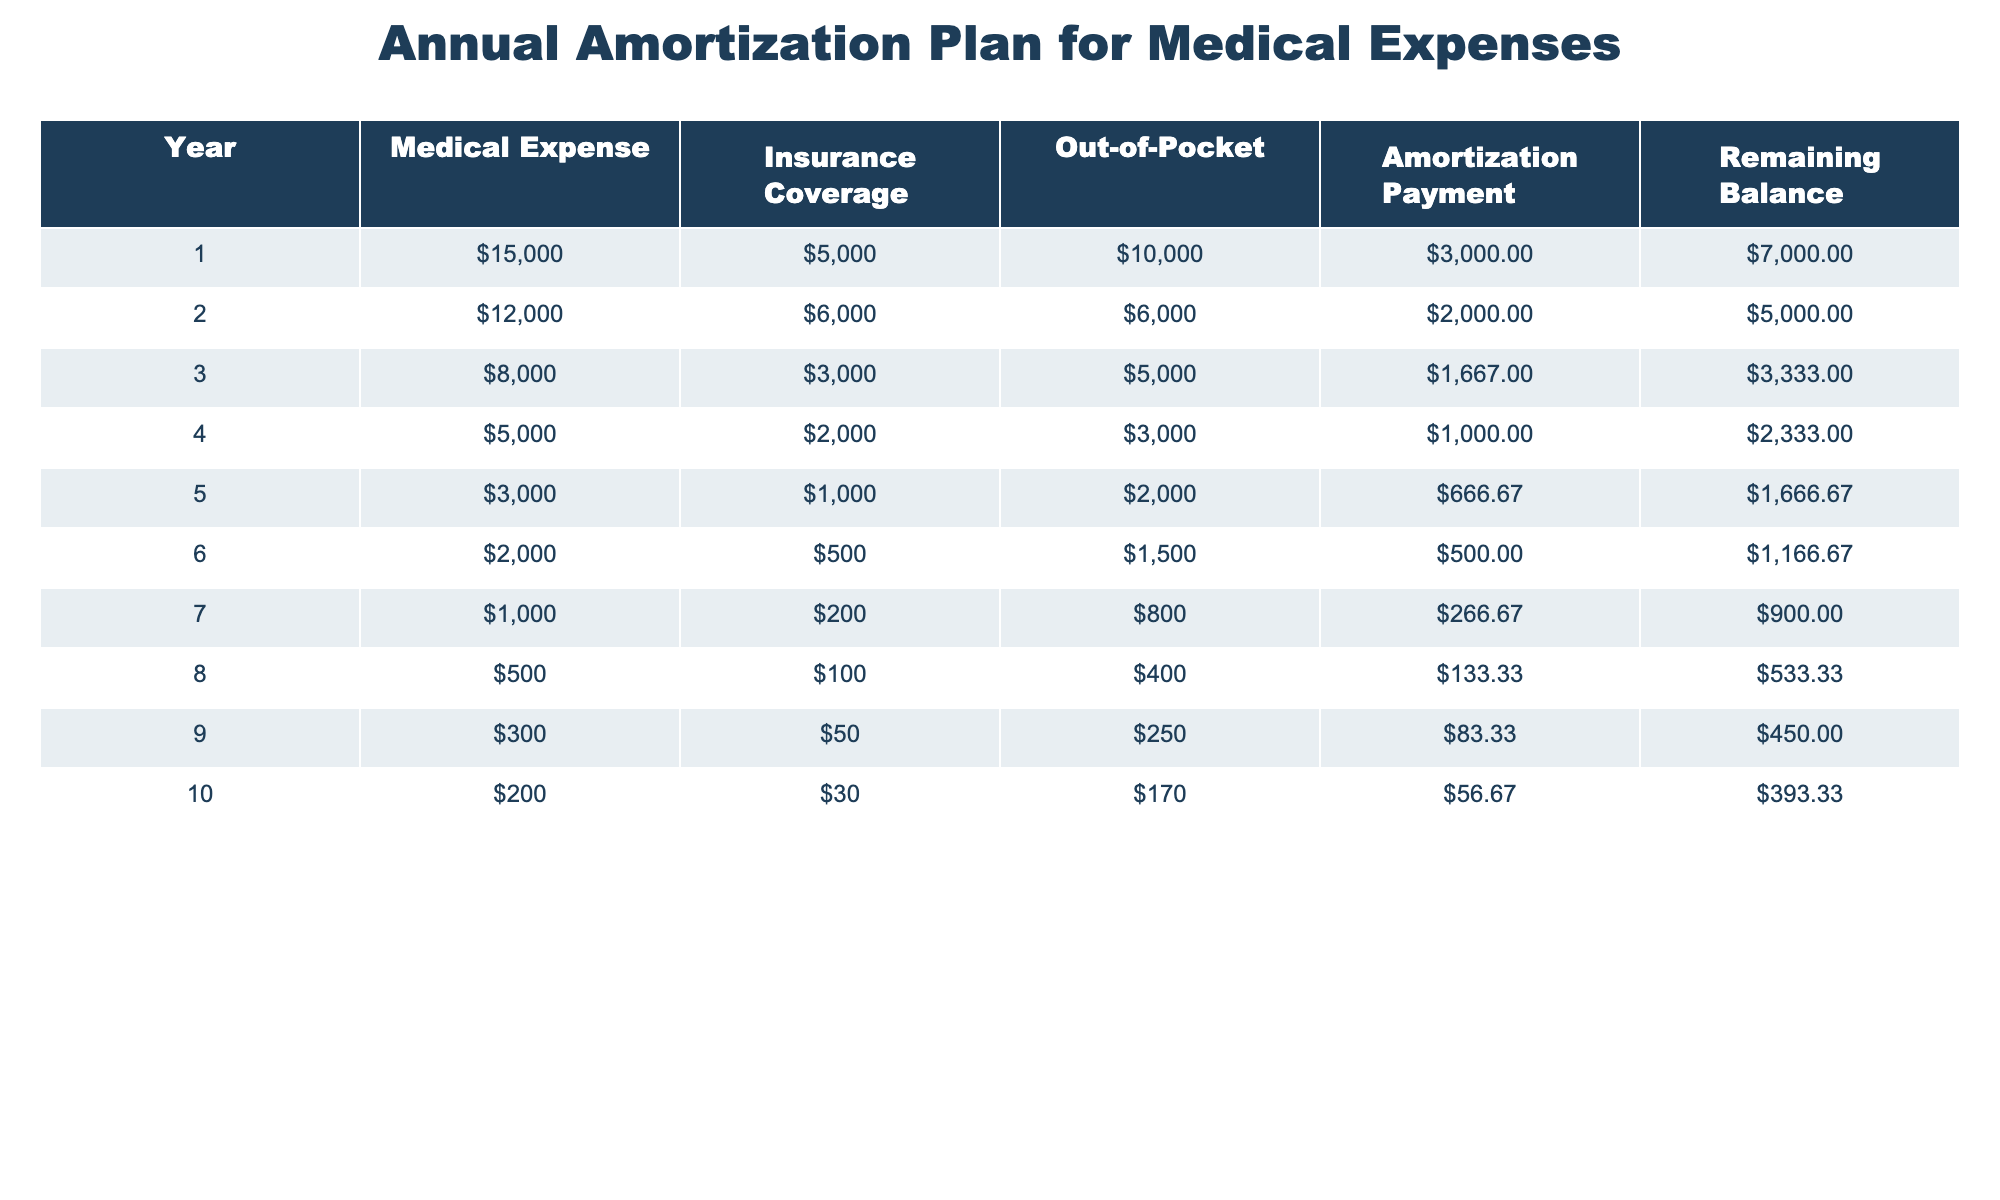What is the total medical expense over the 10 years? To find the total medical expense, we add the medical expenses from each year (15000 + 12000 + 8000 + 5000 + 3000 + 2000 + 1000 + 500 + 300 + 200) which equals 50000.
Answer: 50000 In which year did out-of-pocket expenses decrease the most compared to the previous year? To determine the year with the greatest decrease, we calculate the difference in out-of-pocket expenses between adjacent years. The differences are: Year 1 to Year 2 (10000 - 6000 = 4000), Year 2 to Year 3 (6000 - 5000 = 1000), Year 3 to Year 4 (5000 - 3000 = 2000), and track this until Year 9. The maximum decrease is between Year 1 and Year 2 (4000).
Answer: Year 1 What is the remaining balance after Year 5? The remaining balance after Year 5 is directly provided in the table as 1666.67.
Answer: 1666.67 What is the average annual amortization payment for the first three years? To calculate the average annual amortization payment for the first three years, we sum the amortization payments for Years 1, 2, and 3 (3000 + 2000 + 1667). This equals 6667, and then we divide by 3 (6667 / 3) which results in approximately 2222.33.
Answer: 2222.33 Is the insurance coverage in Year 4 greater than the insurance coverage in Year 6? We can see from the table that the insurance coverage in Year 4 is 2000 and in Year 6 is 500. Since 2000 is greater than 500, the answer is true.
Answer: Yes What has been the trend in out-of-pocket expenses from Year 1 to Year 10? We can analyze the out-of-pocket expenses across the years: Year 1 (10000), Year 2 (6000), Year 3 (5000), Year 4 (3000), Year 5 (2000), Year 6 (1500), Year 7 (800), Year 8 (400), Year 9 (250), Year 10 (170). The trend shows a consistent decrease in out-of-pocket expenses, signifying improvement.
Answer: Decreasing Which year has the lowest medical expense and what is that amount? Looking at the medical expenses column, we find that Year 10 has the lowest expense of 200.
Answer: 200 What is the total insurance coverage across all 10 years? To find the total insurance coverage, we sum the insurance coverage for each year (5000 + 6000 + 3000 + 2000 + 1000 + 500 + 200 + 100 + 50 + 30), which equals 16980.
Answer: 16980 What percentage of the total medical expenses is covered by insurance? The total medical expenses are 50000, and the total insurance coverage is 16980. We divide the insurance coverage by total medical expenses (16980 / 50000) and multiply by 100 to get the percentage, which results in approximately 33.96%.
Answer: 33.96% 